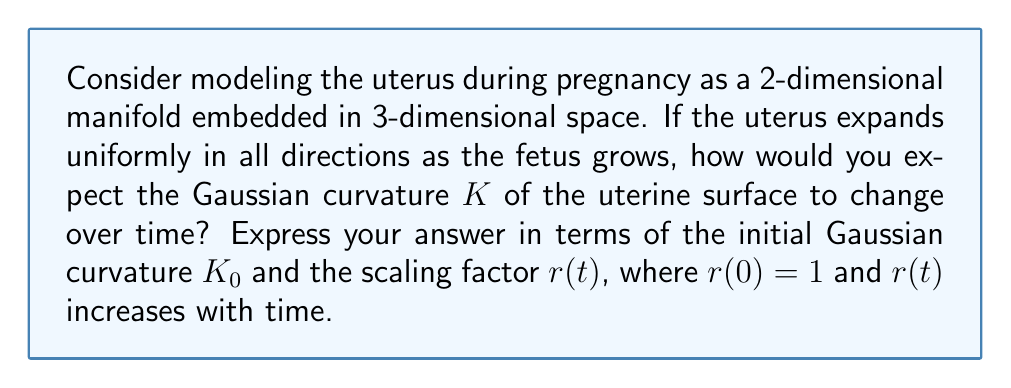Provide a solution to this math problem. Let's approach this step-by-step:

1) The uterus can be modeled as a closed surface in 3D space. As it expands uniformly, it undergoes a uniform scaling transformation.

2) For a surface undergoing uniform scaling by a factor $r$, the new position vector $\mathbf{x}'$ is related to the original position vector $\mathbf{x}$ by:

   $$\mathbf{x}' = r\mathbf{x}$$

3) The first fundamental form coefficients scale as follows:
   
   $$E' = r^2E, \quad F' = r^2F, \quad G' = r^2G$$

4) The second fundamental form coefficients scale as:

   $$L' = rL, \quad M' = rM, \quad N' = rN$$

5) The Gaussian curvature $K$ is given by:

   $$K = \frac{LN - M^2}{EG - F^2}$$

6) Substituting the scaled coefficients:

   $$K' = \frac{r^2(LN - M^2)}{r^4(EG - F^2)} = \frac{1}{r^2} \cdot \frac{LN - M^2}{EG - F^2} = \frac{1}{r^2}K$$

7) Therefore, the Gaussian curvature at time $t$ is related to the initial curvature $K_0$ by:

   $$K(t) = \frac{1}{r(t)^2}K_0$$

This shows that as the uterus expands ($r(t)$ increases), the Gaussian curvature decreases quadratically.
Answer: $K(t) = \frac{K_0}{r(t)^2}$ 